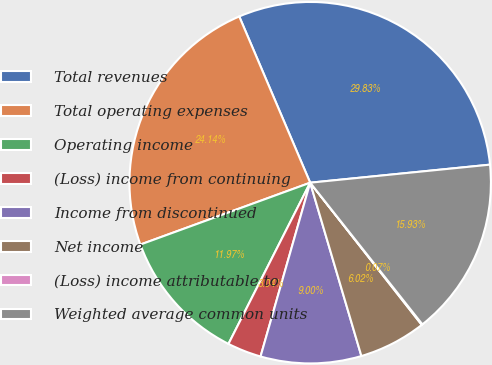<chart> <loc_0><loc_0><loc_500><loc_500><pie_chart><fcel>Total revenues<fcel>Total operating expenses<fcel>Operating income<fcel>(Loss) income from continuing<fcel>Income from discontinued<fcel>Net income<fcel>(Loss) income attributable to<fcel>Weighted average common units<nl><fcel>29.83%<fcel>24.14%<fcel>11.97%<fcel>3.04%<fcel>9.0%<fcel>6.02%<fcel>0.07%<fcel>15.93%<nl></chart> 